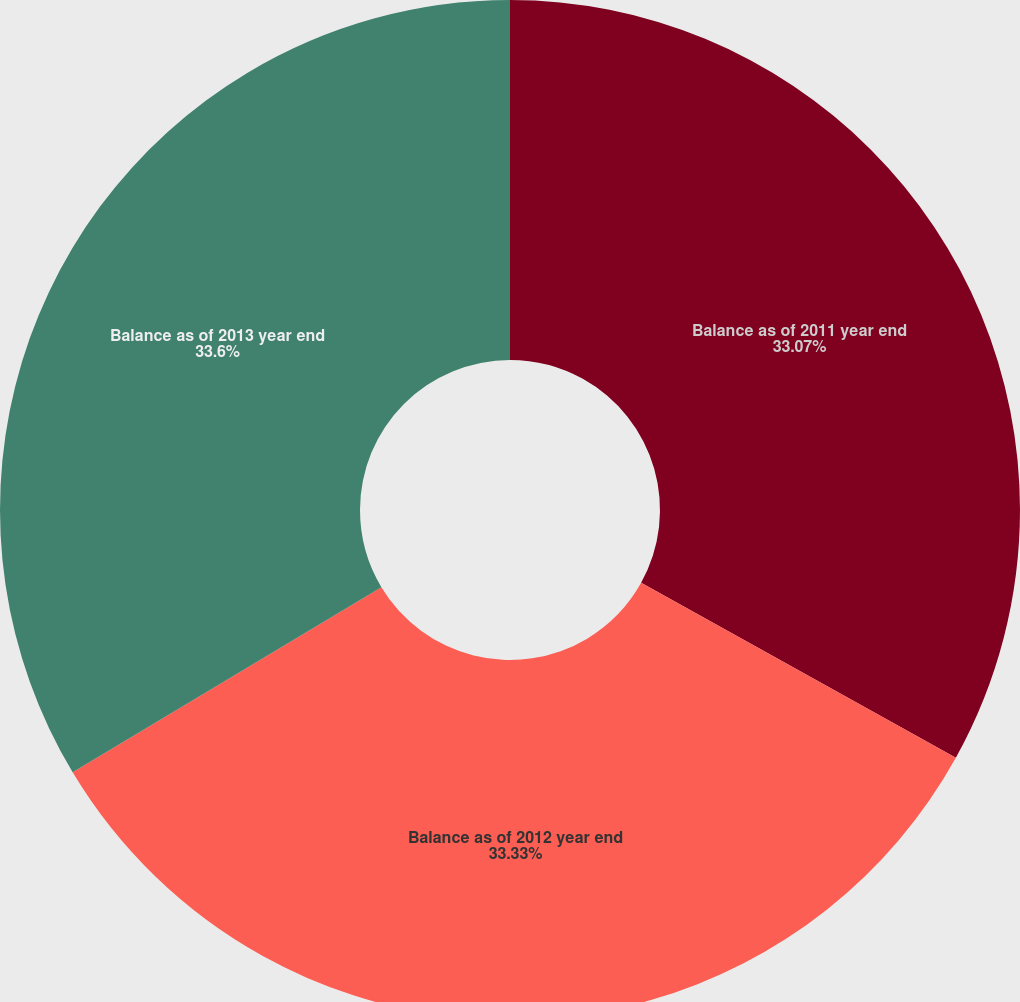Convert chart. <chart><loc_0><loc_0><loc_500><loc_500><pie_chart><fcel>Balance as of 2011 year end<fcel>Balance as of 2012 year end<fcel>Balance as of 2013 year end<nl><fcel>33.07%<fcel>33.33%<fcel>33.6%<nl></chart> 